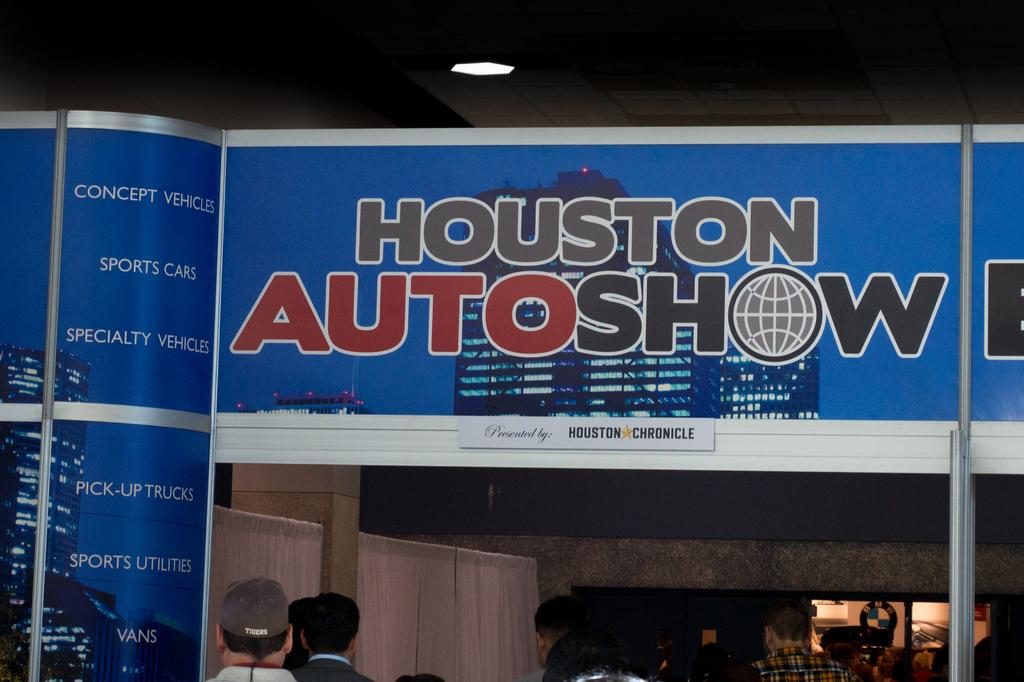What can be seen in the image involving people? There are people standing in the image. What type of signage is present in the image? There are large banners in the image, and they are blue in color. What part of the room can be seen in the image? The ceiling is visible in the image. What is attached to the ceiling in the image? There is a light attached to the ceiling. How many crates are being sorted by the user's sister in the image? There is no sister or crates present in the image. 